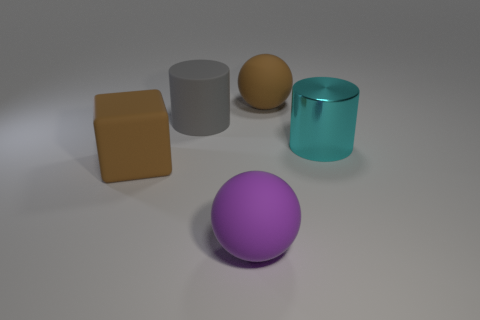There is a rubber object that is right of the block and in front of the gray object; what is its shape?
Offer a terse response. Sphere. There is a big object that is on the right side of the brown sphere; what number of purple rubber balls are on the left side of it?
Keep it short and to the point. 1. Is there anything else that is made of the same material as the large purple thing?
Make the answer very short. Yes. What number of things are either large cylinders right of the gray cylinder or brown matte things?
Provide a short and direct response. 3. What is the size of the brown object to the right of the gray thing?
Provide a short and direct response. Large. What is the material of the big cyan cylinder?
Ensure brevity in your answer.  Metal. There is a large brown object in front of the big rubber ball behind the large rubber block; what shape is it?
Offer a terse response. Cube. How many other objects are the same shape as the cyan thing?
Your answer should be very brief. 1. There is a large brown rubber ball; are there any shiny cylinders on the left side of it?
Give a very brief answer. No. What color is the large matte cube?
Give a very brief answer. Brown. 